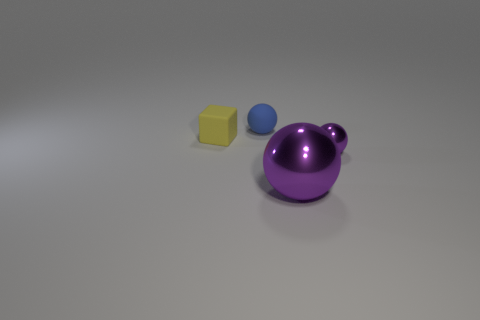Is the big purple object the same shape as the tiny blue thing? While the big purple object and the tiny blue thing share a spherical component, the purple object has an additional structure that makes it not entirely spherical, unlike the small blue ball which is completely spherical. Therefore, while they share some similarities in shape, they are not exactly the same. 